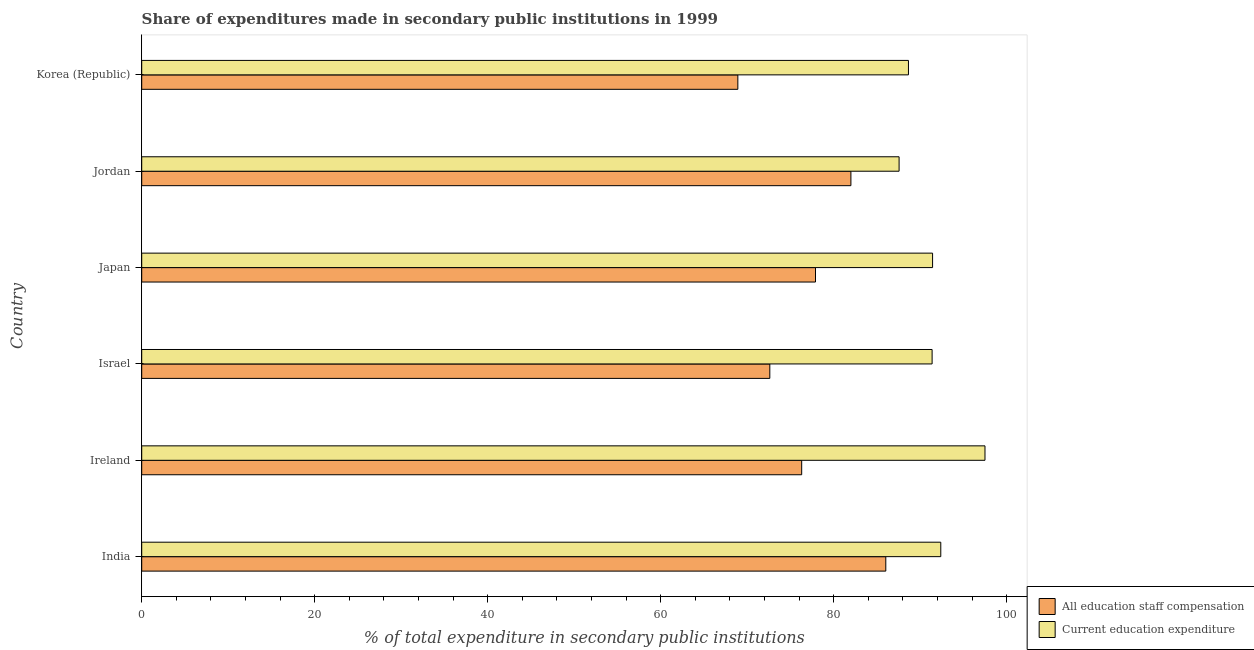Are the number of bars per tick equal to the number of legend labels?
Provide a succinct answer. Yes. Are the number of bars on each tick of the Y-axis equal?
Give a very brief answer. Yes. How many bars are there on the 1st tick from the top?
Give a very brief answer. 2. What is the expenditure in education in India?
Keep it short and to the point. 92.38. Across all countries, what is the maximum expenditure in education?
Provide a short and direct response. 97.49. Across all countries, what is the minimum expenditure in staff compensation?
Offer a very short reply. 68.92. In which country was the expenditure in staff compensation minimum?
Provide a short and direct response. Korea (Republic). What is the total expenditure in staff compensation in the graph?
Your response must be concise. 463.73. What is the difference between the expenditure in staff compensation in India and that in Japan?
Your answer should be compact. 8.13. What is the difference between the expenditure in staff compensation in Israel and the expenditure in education in India?
Ensure brevity in your answer.  -19.76. What is the average expenditure in staff compensation per country?
Provide a short and direct response. 77.29. What is the difference between the expenditure in education and expenditure in staff compensation in Korea (Republic)?
Provide a succinct answer. 19.72. In how many countries, is the expenditure in education greater than 60 %?
Offer a very short reply. 6. What is the ratio of the expenditure in staff compensation in India to that in Jordan?
Offer a very short reply. 1.05. Is the expenditure in staff compensation in Jordan less than that in Korea (Republic)?
Ensure brevity in your answer.  No. Is the difference between the expenditure in staff compensation in India and Israel greater than the difference between the expenditure in education in India and Israel?
Give a very brief answer. Yes. What is the difference between the highest and the second highest expenditure in staff compensation?
Your response must be concise. 4.03. What is the difference between the highest and the lowest expenditure in staff compensation?
Make the answer very short. 17.11. Is the sum of the expenditure in staff compensation in India and Israel greater than the maximum expenditure in education across all countries?
Provide a succinct answer. Yes. What does the 2nd bar from the top in Ireland represents?
Give a very brief answer. All education staff compensation. What does the 2nd bar from the bottom in Israel represents?
Offer a very short reply. Current education expenditure. Does the graph contain any zero values?
Provide a succinct answer. No. Where does the legend appear in the graph?
Keep it short and to the point. Bottom right. What is the title of the graph?
Ensure brevity in your answer.  Share of expenditures made in secondary public institutions in 1999. What is the label or title of the X-axis?
Offer a very short reply. % of total expenditure in secondary public institutions. What is the label or title of the Y-axis?
Your response must be concise. Country. What is the % of total expenditure in secondary public institutions in All education staff compensation in India?
Offer a terse response. 86.02. What is the % of total expenditure in secondary public institutions of Current education expenditure in India?
Provide a short and direct response. 92.38. What is the % of total expenditure in secondary public institutions in All education staff compensation in Ireland?
Your answer should be very brief. 76.3. What is the % of total expenditure in secondary public institutions of Current education expenditure in Ireland?
Your answer should be very brief. 97.49. What is the % of total expenditure in secondary public institutions in All education staff compensation in Israel?
Offer a terse response. 72.61. What is the % of total expenditure in secondary public institutions in Current education expenditure in Israel?
Your answer should be compact. 91.37. What is the % of total expenditure in secondary public institutions in All education staff compensation in Japan?
Offer a terse response. 77.89. What is the % of total expenditure in secondary public institutions of Current education expenditure in Japan?
Make the answer very short. 91.43. What is the % of total expenditure in secondary public institutions of All education staff compensation in Jordan?
Provide a short and direct response. 81.99. What is the % of total expenditure in secondary public institutions of Current education expenditure in Jordan?
Offer a terse response. 87.56. What is the % of total expenditure in secondary public institutions in All education staff compensation in Korea (Republic)?
Offer a very short reply. 68.92. What is the % of total expenditure in secondary public institutions in Current education expenditure in Korea (Republic)?
Offer a terse response. 88.64. Across all countries, what is the maximum % of total expenditure in secondary public institutions of All education staff compensation?
Provide a succinct answer. 86.02. Across all countries, what is the maximum % of total expenditure in secondary public institutions in Current education expenditure?
Your response must be concise. 97.49. Across all countries, what is the minimum % of total expenditure in secondary public institutions in All education staff compensation?
Your response must be concise. 68.92. Across all countries, what is the minimum % of total expenditure in secondary public institutions in Current education expenditure?
Ensure brevity in your answer.  87.56. What is the total % of total expenditure in secondary public institutions of All education staff compensation in the graph?
Your response must be concise. 463.73. What is the total % of total expenditure in secondary public institutions in Current education expenditure in the graph?
Provide a succinct answer. 548.86. What is the difference between the % of total expenditure in secondary public institutions in All education staff compensation in India and that in Ireland?
Ensure brevity in your answer.  9.72. What is the difference between the % of total expenditure in secondary public institutions in Current education expenditure in India and that in Ireland?
Ensure brevity in your answer.  -5.11. What is the difference between the % of total expenditure in secondary public institutions of All education staff compensation in India and that in Israel?
Your answer should be compact. 13.41. What is the difference between the % of total expenditure in secondary public institutions of Current education expenditure in India and that in Israel?
Offer a very short reply. 1. What is the difference between the % of total expenditure in secondary public institutions of All education staff compensation in India and that in Japan?
Your answer should be compact. 8.13. What is the difference between the % of total expenditure in secondary public institutions of Current education expenditure in India and that in Japan?
Offer a very short reply. 0.95. What is the difference between the % of total expenditure in secondary public institutions of All education staff compensation in India and that in Jordan?
Your answer should be compact. 4.03. What is the difference between the % of total expenditure in secondary public institutions in Current education expenditure in India and that in Jordan?
Make the answer very short. 4.82. What is the difference between the % of total expenditure in secondary public institutions of All education staff compensation in India and that in Korea (Republic)?
Offer a very short reply. 17.11. What is the difference between the % of total expenditure in secondary public institutions of Current education expenditure in India and that in Korea (Republic)?
Provide a short and direct response. 3.74. What is the difference between the % of total expenditure in secondary public institutions of All education staff compensation in Ireland and that in Israel?
Provide a short and direct response. 3.68. What is the difference between the % of total expenditure in secondary public institutions of Current education expenditure in Ireland and that in Israel?
Provide a short and direct response. 6.11. What is the difference between the % of total expenditure in secondary public institutions of All education staff compensation in Ireland and that in Japan?
Make the answer very short. -1.6. What is the difference between the % of total expenditure in secondary public institutions of Current education expenditure in Ireland and that in Japan?
Your answer should be compact. 6.06. What is the difference between the % of total expenditure in secondary public institutions of All education staff compensation in Ireland and that in Jordan?
Your answer should be compact. -5.69. What is the difference between the % of total expenditure in secondary public institutions in Current education expenditure in Ireland and that in Jordan?
Keep it short and to the point. 9.93. What is the difference between the % of total expenditure in secondary public institutions of All education staff compensation in Ireland and that in Korea (Republic)?
Ensure brevity in your answer.  7.38. What is the difference between the % of total expenditure in secondary public institutions in Current education expenditure in Ireland and that in Korea (Republic)?
Provide a short and direct response. 8.85. What is the difference between the % of total expenditure in secondary public institutions in All education staff compensation in Israel and that in Japan?
Your answer should be very brief. -5.28. What is the difference between the % of total expenditure in secondary public institutions in Current education expenditure in Israel and that in Japan?
Offer a terse response. -0.05. What is the difference between the % of total expenditure in secondary public institutions in All education staff compensation in Israel and that in Jordan?
Give a very brief answer. -9.38. What is the difference between the % of total expenditure in secondary public institutions in Current education expenditure in Israel and that in Jordan?
Give a very brief answer. 3.82. What is the difference between the % of total expenditure in secondary public institutions of All education staff compensation in Israel and that in Korea (Republic)?
Make the answer very short. 3.7. What is the difference between the % of total expenditure in secondary public institutions in Current education expenditure in Israel and that in Korea (Republic)?
Offer a terse response. 2.73. What is the difference between the % of total expenditure in secondary public institutions in All education staff compensation in Japan and that in Jordan?
Keep it short and to the point. -4.09. What is the difference between the % of total expenditure in secondary public institutions of Current education expenditure in Japan and that in Jordan?
Keep it short and to the point. 3.87. What is the difference between the % of total expenditure in secondary public institutions of All education staff compensation in Japan and that in Korea (Republic)?
Ensure brevity in your answer.  8.98. What is the difference between the % of total expenditure in secondary public institutions of Current education expenditure in Japan and that in Korea (Republic)?
Provide a short and direct response. 2.79. What is the difference between the % of total expenditure in secondary public institutions in All education staff compensation in Jordan and that in Korea (Republic)?
Give a very brief answer. 13.07. What is the difference between the % of total expenditure in secondary public institutions in Current education expenditure in Jordan and that in Korea (Republic)?
Your response must be concise. -1.08. What is the difference between the % of total expenditure in secondary public institutions of All education staff compensation in India and the % of total expenditure in secondary public institutions of Current education expenditure in Ireland?
Offer a terse response. -11.47. What is the difference between the % of total expenditure in secondary public institutions in All education staff compensation in India and the % of total expenditure in secondary public institutions in Current education expenditure in Israel?
Your answer should be compact. -5.35. What is the difference between the % of total expenditure in secondary public institutions in All education staff compensation in India and the % of total expenditure in secondary public institutions in Current education expenditure in Japan?
Provide a short and direct response. -5.41. What is the difference between the % of total expenditure in secondary public institutions in All education staff compensation in India and the % of total expenditure in secondary public institutions in Current education expenditure in Jordan?
Your response must be concise. -1.54. What is the difference between the % of total expenditure in secondary public institutions in All education staff compensation in India and the % of total expenditure in secondary public institutions in Current education expenditure in Korea (Republic)?
Provide a succinct answer. -2.62. What is the difference between the % of total expenditure in secondary public institutions of All education staff compensation in Ireland and the % of total expenditure in secondary public institutions of Current education expenditure in Israel?
Your response must be concise. -15.08. What is the difference between the % of total expenditure in secondary public institutions in All education staff compensation in Ireland and the % of total expenditure in secondary public institutions in Current education expenditure in Japan?
Offer a very short reply. -15.13. What is the difference between the % of total expenditure in secondary public institutions of All education staff compensation in Ireland and the % of total expenditure in secondary public institutions of Current education expenditure in Jordan?
Provide a short and direct response. -11.26. What is the difference between the % of total expenditure in secondary public institutions in All education staff compensation in Ireland and the % of total expenditure in secondary public institutions in Current education expenditure in Korea (Republic)?
Offer a very short reply. -12.34. What is the difference between the % of total expenditure in secondary public institutions of All education staff compensation in Israel and the % of total expenditure in secondary public institutions of Current education expenditure in Japan?
Your answer should be very brief. -18.82. What is the difference between the % of total expenditure in secondary public institutions in All education staff compensation in Israel and the % of total expenditure in secondary public institutions in Current education expenditure in Jordan?
Offer a terse response. -14.95. What is the difference between the % of total expenditure in secondary public institutions of All education staff compensation in Israel and the % of total expenditure in secondary public institutions of Current education expenditure in Korea (Republic)?
Provide a succinct answer. -16.03. What is the difference between the % of total expenditure in secondary public institutions in All education staff compensation in Japan and the % of total expenditure in secondary public institutions in Current education expenditure in Jordan?
Your response must be concise. -9.66. What is the difference between the % of total expenditure in secondary public institutions of All education staff compensation in Japan and the % of total expenditure in secondary public institutions of Current education expenditure in Korea (Republic)?
Your answer should be compact. -10.75. What is the difference between the % of total expenditure in secondary public institutions in All education staff compensation in Jordan and the % of total expenditure in secondary public institutions in Current education expenditure in Korea (Republic)?
Offer a very short reply. -6.65. What is the average % of total expenditure in secondary public institutions in All education staff compensation per country?
Offer a terse response. 77.29. What is the average % of total expenditure in secondary public institutions of Current education expenditure per country?
Offer a very short reply. 91.48. What is the difference between the % of total expenditure in secondary public institutions of All education staff compensation and % of total expenditure in secondary public institutions of Current education expenditure in India?
Keep it short and to the point. -6.36. What is the difference between the % of total expenditure in secondary public institutions in All education staff compensation and % of total expenditure in secondary public institutions in Current education expenditure in Ireland?
Your answer should be compact. -21.19. What is the difference between the % of total expenditure in secondary public institutions in All education staff compensation and % of total expenditure in secondary public institutions in Current education expenditure in Israel?
Give a very brief answer. -18.76. What is the difference between the % of total expenditure in secondary public institutions in All education staff compensation and % of total expenditure in secondary public institutions in Current education expenditure in Japan?
Your response must be concise. -13.53. What is the difference between the % of total expenditure in secondary public institutions of All education staff compensation and % of total expenditure in secondary public institutions of Current education expenditure in Jordan?
Your answer should be compact. -5.57. What is the difference between the % of total expenditure in secondary public institutions of All education staff compensation and % of total expenditure in secondary public institutions of Current education expenditure in Korea (Republic)?
Give a very brief answer. -19.72. What is the ratio of the % of total expenditure in secondary public institutions of All education staff compensation in India to that in Ireland?
Your response must be concise. 1.13. What is the ratio of the % of total expenditure in secondary public institutions in Current education expenditure in India to that in Ireland?
Your answer should be very brief. 0.95. What is the ratio of the % of total expenditure in secondary public institutions of All education staff compensation in India to that in Israel?
Your response must be concise. 1.18. What is the ratio of the % of total expenditure in secondary public institutions of All education staff compensation in India to that in Japan?
Provide a short and direct response. 1.1. What is the ratio of the % of total expenditure in secondary public institutions of Current education expenditure in India to that in Japan?
Give a very brief answer. 1.01. What is the ratio of the % of total expenditure in secondary public institutions in All education staff compensation in India to that in Jordan?
Provide a short and direct response. 1.05. What is the ratio of the % of total expenditure in secondary public institutions of Current education expenditure in India to that in Jordan?
Your answer should be very brief. 1.05. What is the ratio of the % of total expenditure in secondary public institutions of All education staff compensation in India to that in Korea (Republic)?
Make the answer very short. 1.25. What is the ratio of the % of total expenditure in secondary public institutions of Current education expenditure in India to that in Korea (Republic)?
Give a very brief answer. 1.04. What is the ratio of the % of total expenditure in secondary public institutions of All education staff compensation in Ireland to that in Israel?
Offer a very short reply. 1.05. What is the ratio of the % of total expenditure in secondary public institutions in Current education expenditure in Ireland to that in Israel?
Keep it short and to the point. 1.07. What is the ratio of the % of total expenditure in secondary public institutions of All education staff compensation in Ireland to that in Japan?
Provide a short and direct response. 0.98. What is the ratio of the % of total expenditure in secondary public institutions of Current education expenditure in Ireland to that in Japan?
Offer a very short reply. 1.07. What is the ratio of the % of total expenditure in secondary public institutions of All education staff compensation in Ireland to that in Jordan?
Your answer should be very brief. 0.93. What is the ratio of the % of total expenditure in secondary public institutions in Current education expenditure in Ireland to that in Jordan?
Provide a short and direct response. 1.11. What is the ratio of the % of total expenditure in secondary public institutions of All education staff compensation in Ireland to that in Korea (Republic)?
Provide a short and direct response. 1.11. What is the ratio of the % of total expenditure in secondary public institutions of Current education expenditure in Ireland to that in Korea (Republic)?
Ensure brevity in your answer.  1.1. What is the ratio of the % of total expenditure in secondary public institutions of All education staff compensation in Israel to that in Japan?
Offer a terse response. 0.93. What is the ratio of the % of total expenditure in secondary public institutions of Current education expenditure in Israel to that in Japan?
Provide a short and direct response. 1. What is the ratio of the % of total expenditure in secondary public institutions in All education staff compensation in Israel to that in Jordan?
Ensure brevity in your answer.  0.89. What is the ratio of the % of total expenditure in secondary public institutions in Current education expenditure in Israel to that in Jordan?
Provide a short and direct response. 1.04. What is the ratio of the % of total expenditure in secondary public institutions in All education staff compensation in Israel to that in Korea (Republic)?
Make the answer very short. 1.05. What is the ratio of the % of total expenditure in secondary public institutions in Current education expenditure in Israel to that in Korea (Republic)?
Your response must be concise. 1.03. What is the ratio of the % of total expenditure in secondary public institutions of All education staff compensation in Japan to that in Jordan?
Provide a short and direct response. 0.95. What is the ratio of the % of total expenditure in secondary public institutions in Current education expenditure in Japan to that in Jordan?
Provide a succinct answer. 1.04. What is the ratio of the % of total expenditure in secondary public institutions in All education staff compensation in Japan to that in Korea (Republic)?
Your answer should be compact. 1.13. What is the ratio of the % of total expenditure in secondary public institutions in Current education expenditure in Japan to that in Korea (Republic)?
Your answer should be very brief. 1.03. What is the ratio of the % of total expenditure in secondary public institutions in All education staff compensation in Jordan to that in Korea (Republic)?
Offer a terse response. 1.19. What is the ratio of the % of total expenditure in secondary public institutions in Current education expenditure in Jordan to that in Korea (Republic)?
Provide a short and direct response. 0.99. What is the difference between the highest and the second highest % of total expenditure in secondary public institutions of All education staff compensation?
Give a very brief answer. 4.03. What is the difference between the highest and the second highest % of total expenditure in secondary public institutions in Current education expenditure?
Keep it short and to the point. 5.11. What is the difference between the highest and the lowest % of total expenditure in secondary public institutions of All education staff compensation?
Your response must be concise. 17.11. What is the difference between the highest and the lowest % of total expenditure in secondary public institutions in Current education expenditure?
Offer a very short reply. 9.93. 